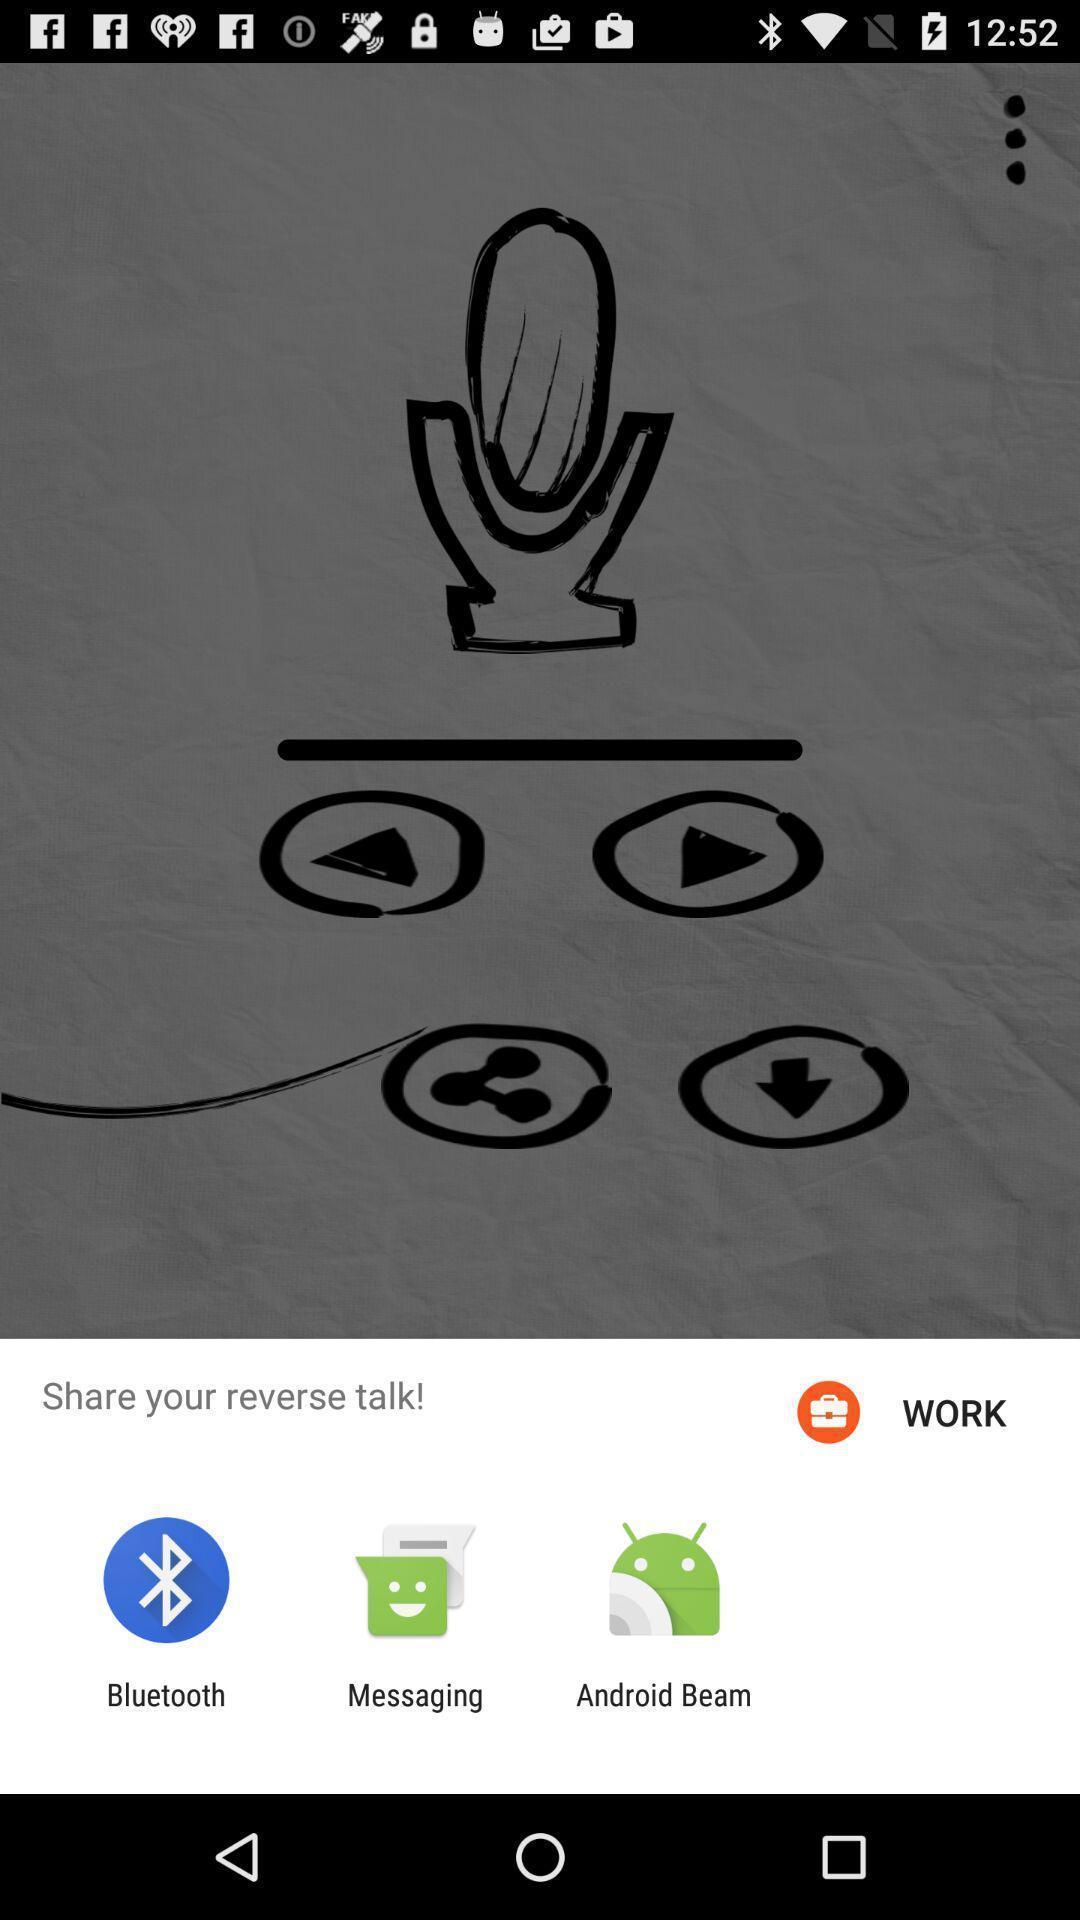Tell me what you see in this picture. Sharing options in the app. 